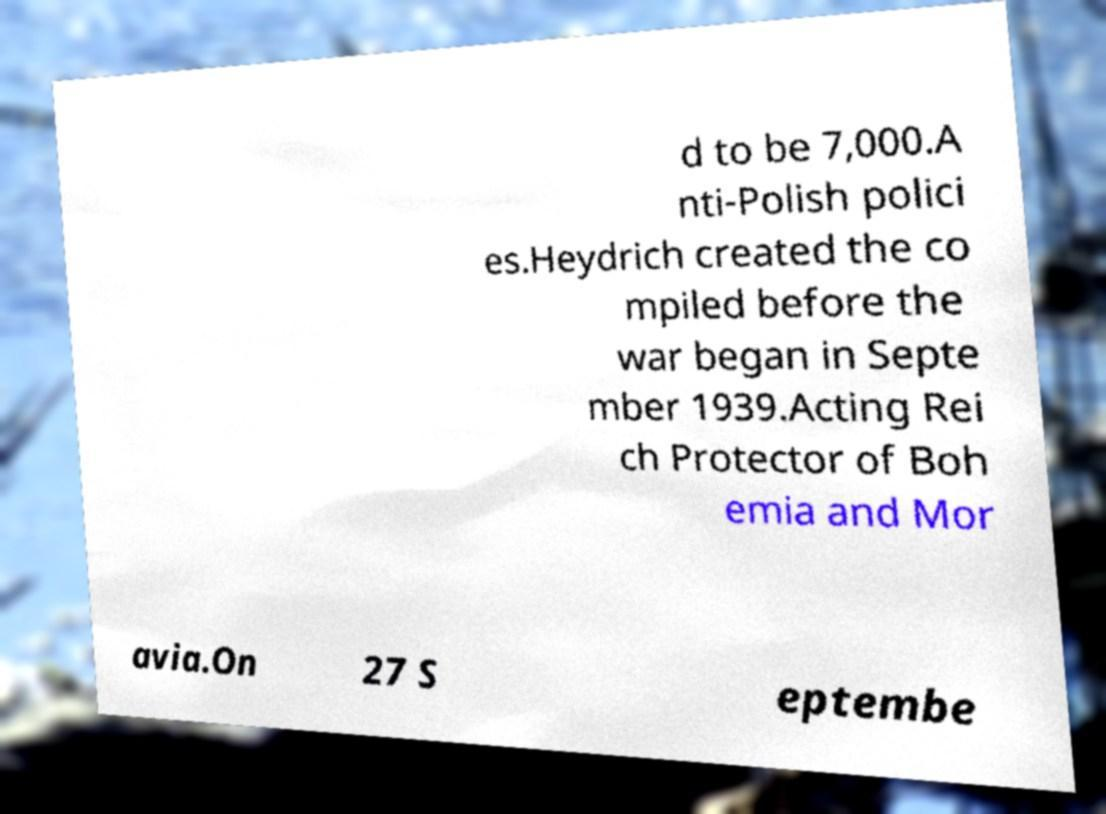What messages or text are displayed in this image? I need them in a readable, typed format. d to be 7,000.A nti-Polish polici es.Heydrich created the co mpiled before the war began in Septe mber 1939.Acting Rei ch Protector of Boh emia and Mor avia.On 27 S eptembe 